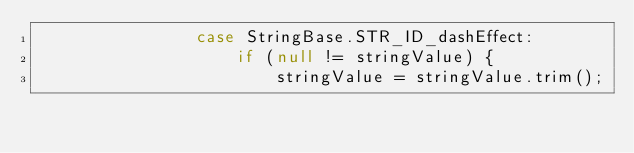<code> <loc_0><loc_0><loc_500><loc_500><_Java_>                case StringBase.STR_ID_dashEffect:
                    if (null != stringValue) {
                        stringValue = stringValue.trim();</code> 